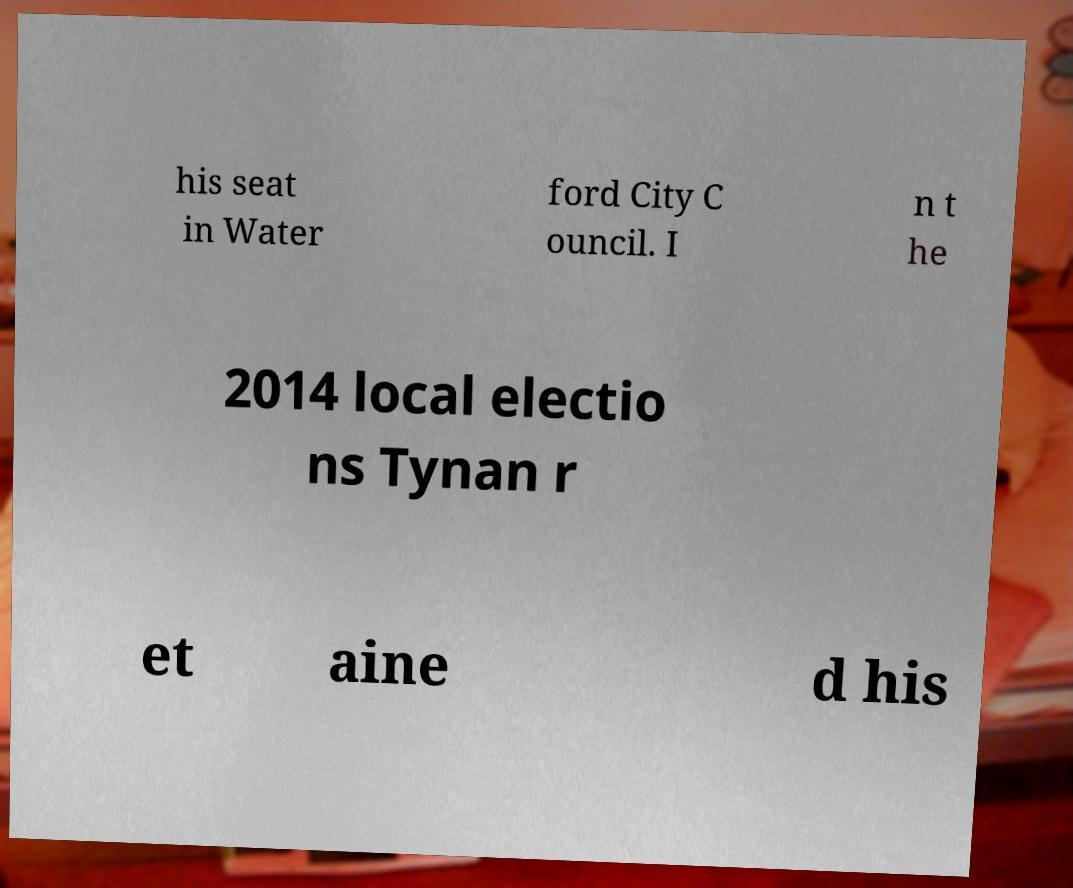Can you read and provide the text displayed in the image?This photo seems to have some interesting text. Can you extract and type it out for me? his seat in Water ford City C ouncil. I n t he 2014 local electio ns Tynan r et aine d his 